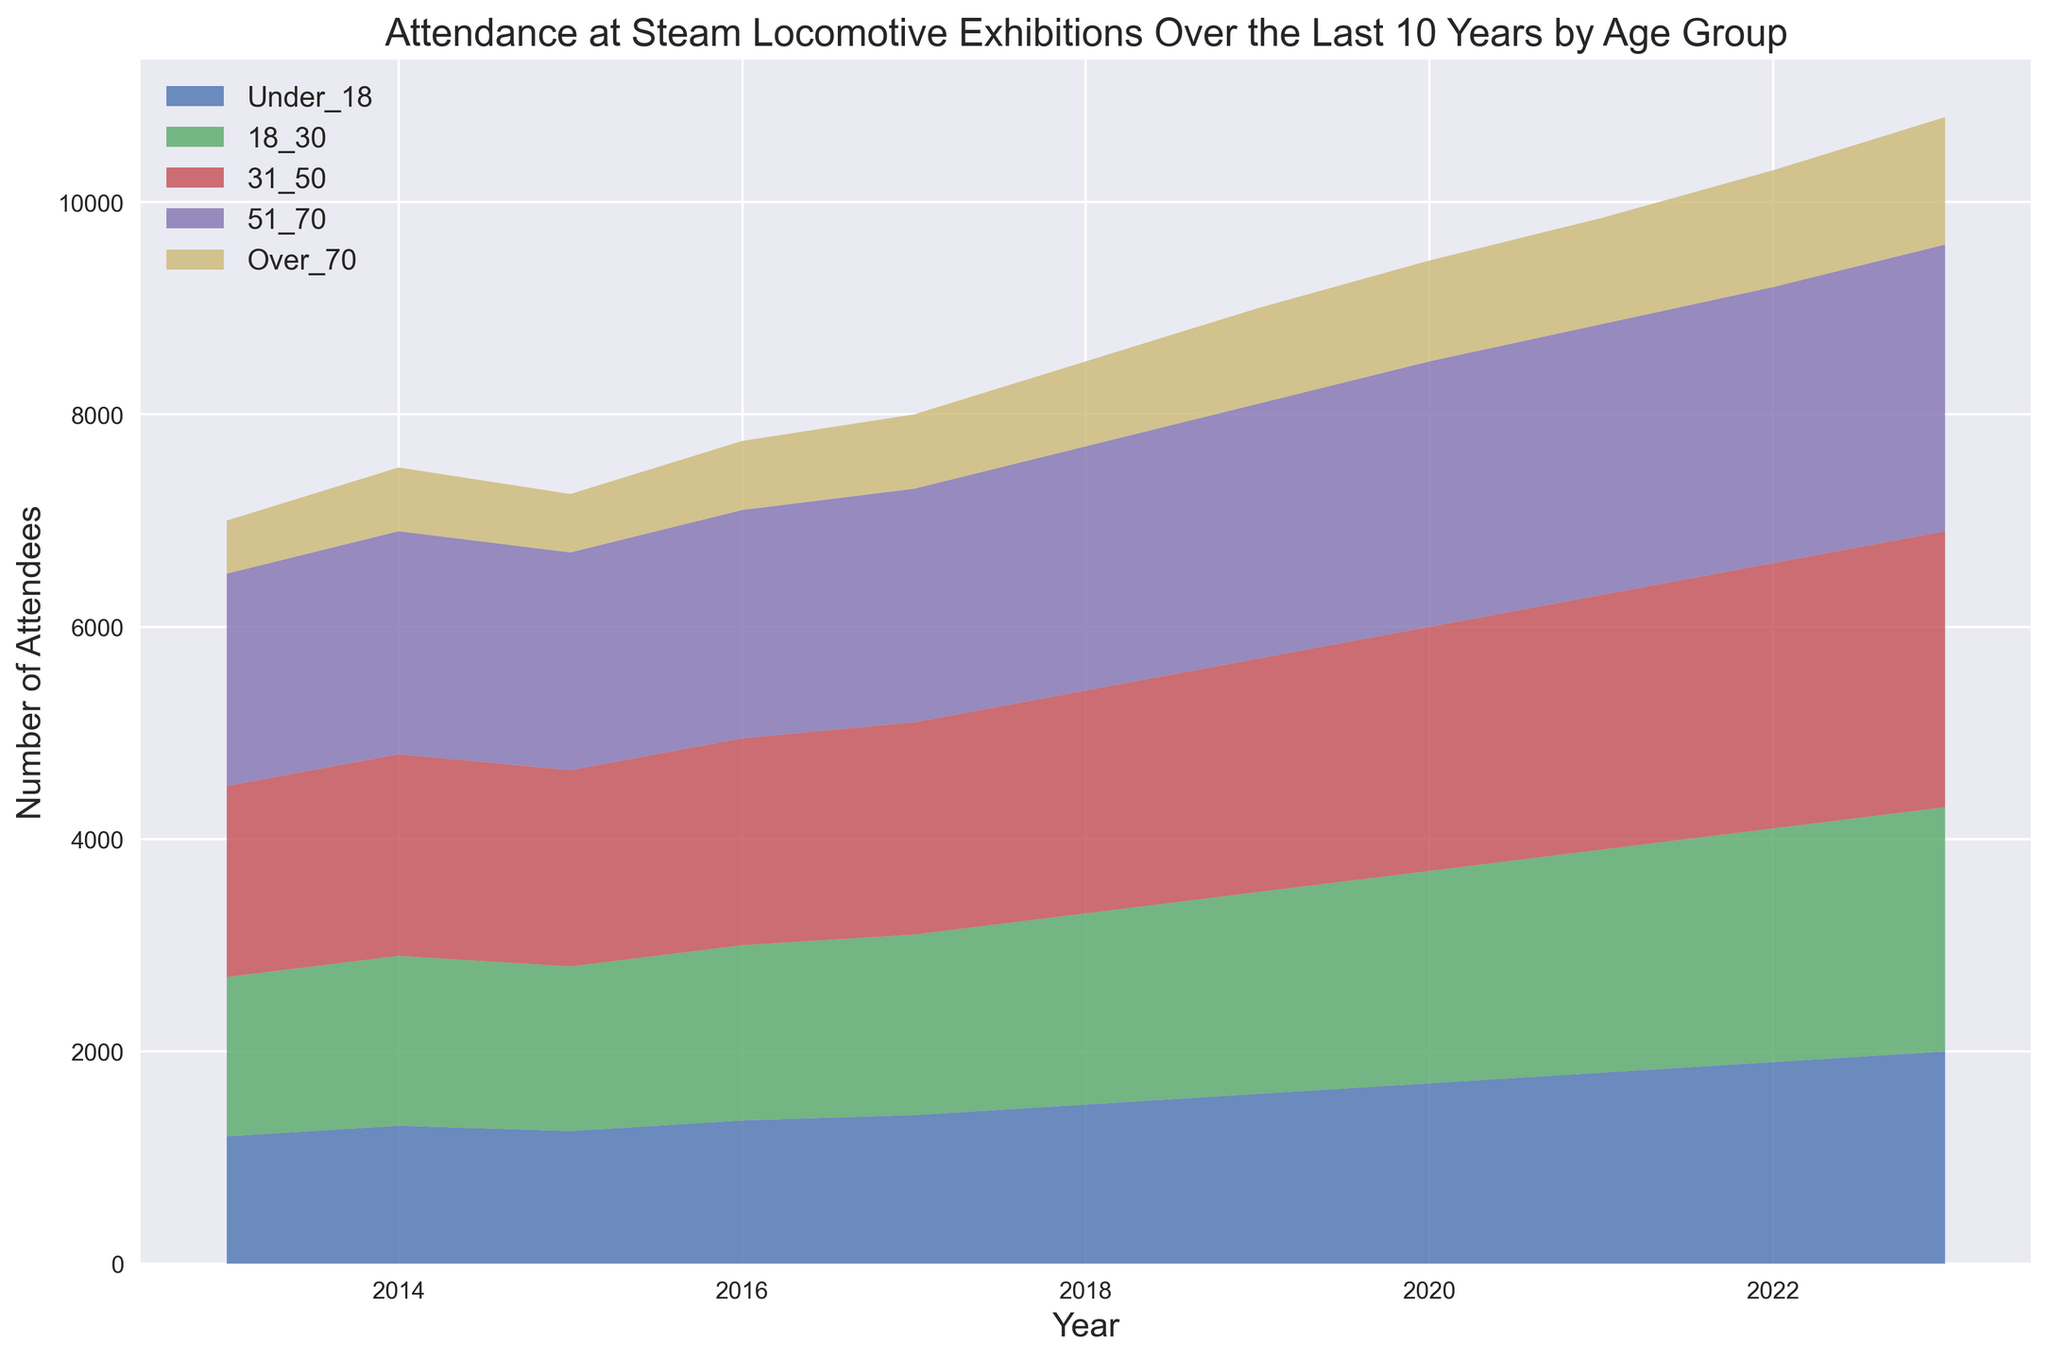How has the attendance for the 18-30 age group changed from 2013 to 2023? To find the change in attendance for the 18-30 age group, look at the y-values for this group in 2013 and 2023. The value in 2013 is 1500 and in 2023 is 2300. The change is calculated as 2300 - 1500 = 800.
Answer: 800 Which age group saw the largest increase in attendance over the 10 years? Compare the differences in attendance for each age group from 2013 to 2023 by subtracting the 2013 values from the 2023 values for each group. The differences are: Under 18: 2000-1200=800, 18-30: 2300-1500=800, 31-50: 2600-1800=800, 51-70: 2700-2000=700, Over 70: 1200-500=700. The largest increase is for Under 18, 18-30, and 31-50 at 800 attendees each.
Answer: Under 18, 18-30, and 31-50 In which year did the Under 18 age group surpass 1500 attendees for the first time? To determine this, look at the values for the Under 18 age group over the years. In 2018, the number of attendees is 1500, and in 2019 it rises to 1600. Therefore, the first year it surpasses 1500 is 2019.
Answer: 2019 Which year shows the smallest total attendance? Sum the values of all age groups for each year, then compare to find the smallest total. For example, for 2013: 1200 + 1500 + 1800 + 2000 + 500 = 7000. Repeat for all years. The smallest sum is for 2013.
Answer: 2013 What is the average annual attendance for the Over 70 age group across the 10 years? Add the attendance numbers for the Over 70 age group for each year and divide by the number of years. The numbers are 500 + 600 + 550 + 650 + 700 + 800 + 900 + 950 + 1000 + 1100 + 1200. Summing these: 500 + 600 + 550 + 650 + 700 + 800 + 900 + 950 + 1000 + 1100 + 1200 = 8950, and dividing by 11 years: 8950/11 ≈ 813.64.
Answer: 813.64 Which age group's attendance is growing at the fastest rate? Calculate the rate of growth for each age group by finding the difference between the 2023 and 2013 values, then compare. The results are: Under 18: (2000-1200)/10 = 80 per year, 18-30: (2300-1500)/10 = 80 per year, 31-50: (2600-1800)/10 = 80 per year, 51-70: (2700-2000)/10 = 70 per year, Over 70: (1200-500)/10 = 70 per year. The fastest growth rate is 80 per year for Under 18, 18-30, and 31-50.
Answer: Under 18, 18-30, and 31-50 How did the attendance for the 51-70 age group in 2020 compare to 2019? Find the attendance values for the 51-70 age group in 2019 and 2020, then compare. In 2019, the value is 2400, and in 2020, it is 2500. The difference is 2500 - 2400 = 100 more attendees in 2020.
Answer: 100 more attendees 